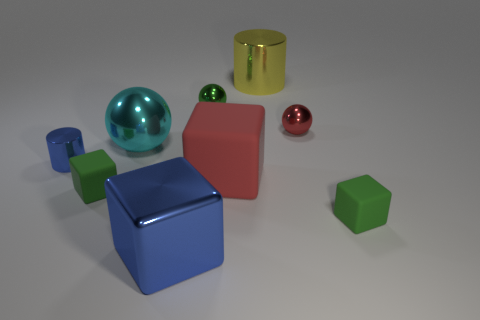Could you describe the lighting and shadows in the image? The lighting in the image is soft and diffuse, coming from the upper left side, which creates gentle shadows on the right side of the objects, suggesting an indoor setting with a single light source. Does the lighting affect the color perception of the objects? Yes, the lighting may slightly alter how we perceive the colors, making them appear less saturated in the shadows while enhancing their vibrancy where the light hits them directly. 